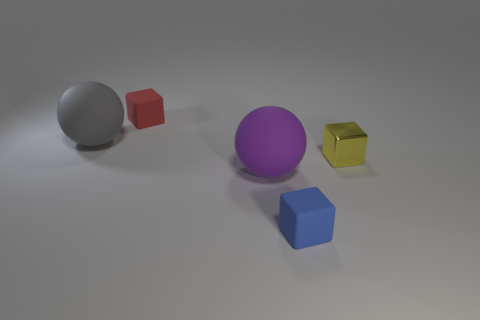Subtract all rubber blocks. How many blocks are left? 1 Add 4 tiny metallic objects. How many objects exist? 9 Subtract 1 blocks. How many blocks are left? 2 Subtract all cubes. How many objects are left? 2 Subtract all gray blocks. Subtract all blue spheres. How many blocks are left? 3 Add 3 big red balls. How many big red balls exist? 3 Subtract 1 red blocks. How many objects are left? 4 Subtract all blue things. Subtract all small yellow cylinders. How many objects are left? 4 Add 5 yellow cubes. How many yellow cubes are left? 6 